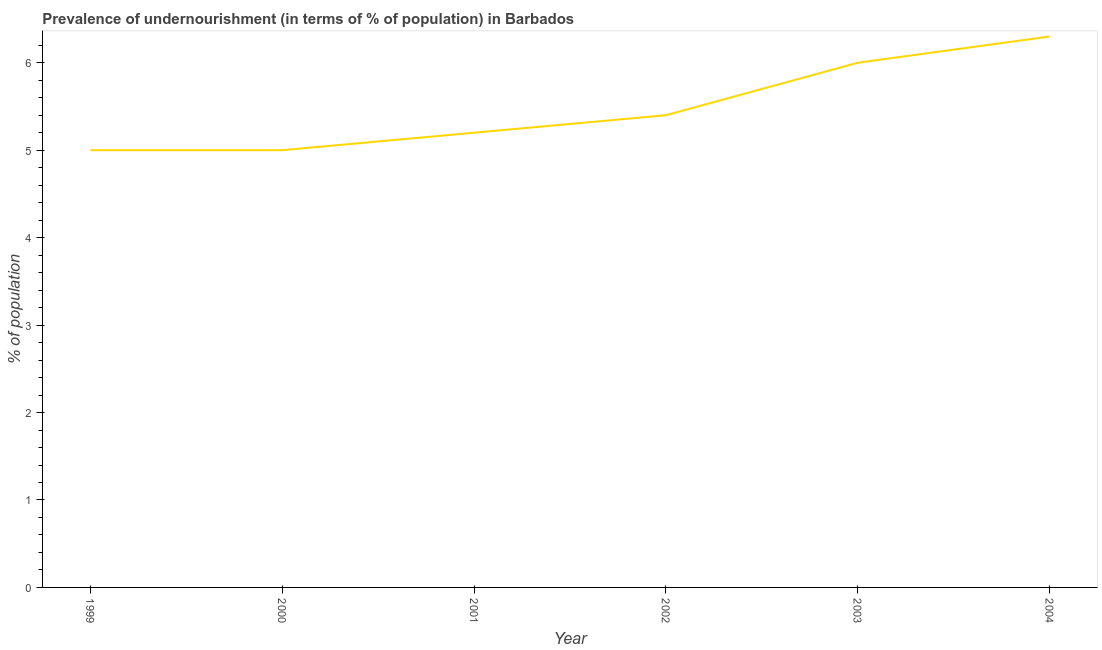Across all years, what is the maximum percentage of undernourished population?
Ensure brevity in your answer.  6.3. In which year was the percentage of undernourished population minimum?
Your response must be concise. 1999. What is the sum of the percentage of undernourished population?
Provide a short and direct response. 32.9. What is the difference between the percentage of undernourished population in 1999 and 2002?
Keep it short and to the point. -0.4. What is the average percentage of undernourished population per year?
Offer a very short reply. 5.48. What is the median percentage of undernourished population?
Give a very brief answer. 5.3. What is the ratio of the percentage of undernourished population in 2001 to that in 2004?
Your response must be concise. 0.83. Is the difference between the percentage of undernourished population in 2002 and 2004 greater than the difference between any two years?
Offer a terse response. No. What is the difference between the highest and the second highest percentage of undernourished population?
Ensure brevity in your answer.  0.3. What is the difference between the highest and the lowest percentage of undernourished population?
Make the answer very short. 1.3. In how many years, is the percentage of undernourished population greater than the average percentage of undernourished population taken over all years?
Provide a short and direct response. 2. How many lines are there?
Your response must be concise. 1. Are the values on the major ticks of Y-axis written in scientific E-notation?
Your answer should be compact. No. Does the graph contain any zero values?
Keep it short and to the point. No. Does the graph contain grids?
Offer a very short reply. No. What is the title of the graph?
Offer a very short reply. Prevalence of undernourishment (in terms of % of population) in Barbados. What is the label or title of the X-axis?
Your response must be concise. Year. What is the label or title of the Y-axis?
Give a very brief answer. % of population. What is the % of population of 2000?
Provide a short and direct response. 5. What is the % of population of 2001?
Keep it short and to the point. 5.2. What is the % of population of 2002?
Give a very brief answer. 5.4. What is the % of population of 2003?
Your answer should be very brief. 6. What is the % of population in 2004?
Make the answer very short. 6.3. What is the difference between the % of population in 1999 and 2000?
Make the answer very short. 0. What is the difference between the % of population in 1999 and 2003?
Keep it short and to the point. -1. What is the difference between the % of population in 1999 and 2004?
Give a very brief answer. -1.3. What is the difference between the % of population in 2000 and 2002?
Provide a short and direct response. -0.4. What is the difference between the % of population in 2000 and 2003?
Your response must be concise. -1. What is the difference between the % of population in 2000 and 2004?
Offer a very short reply. -1.3. What is the difference between the % of population in 2001 and 2002?
Offer a very short reply. -0.2. What is the difference between the % of population in 2001 and 2004?
Provide a succinct answer. -1.1. What is the difference between the % of population in 2002 and 2003?
Provide a short and direct response. -0.6. What is the ratio of the % of population in 1999 to that in 2002?
Your response must be concise. 0.93. What is the ratio of the % of population in 1999 to that in 2003?
Your answer should be compact. 0.83. What is the ratio of the % of population in 1999 to that in 2004?
Your answer should be very brief. 0.79. What is the ratio of the % of population in 2000 to that in 2001?
Give a very brief answer. 0.96. What is the ratio of the % of population in 2000 to that in 2002?
Keep it short and to the point. 0.93. What is the ratio of the % of population in 2000 to that in 2003?
Give a very brief answer. 0.83. What is the ratio of the % of population in 2000 to that in 2004?
Offer a very short reply. 0.79. What is the ratio of the % of population in 2001 to that in 2003?
Offer a terse response. 0.87. What is the ratio of the % of population in 2001 to that in 2004?
Provide a succinct answer. 0.82. What is the ratio of the % of population in 2002 to that in 2003?
Offer a terse response. 0.9. What is the ratio of the % of population in 2002 to that in 2004?
Make the answer very short. 0.86. What is the ratio of the % of population in 2003 to that in 2004?
Keep it short and to the point. 0.95. 